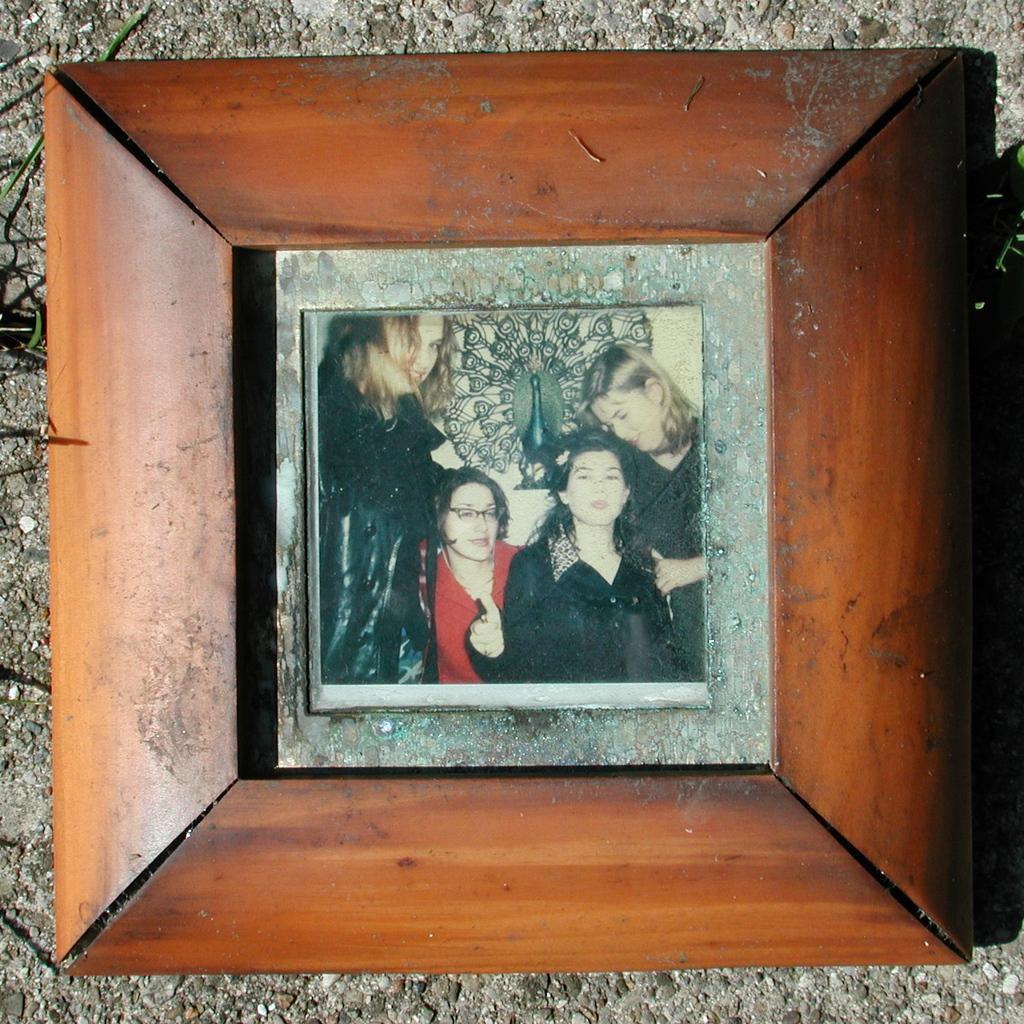Describe this image in one or two sentences. In the center of this picture we can see a wooden picture frame with a picture containing the group of people and some other items and in the background there is an object which seems to be the wall. 